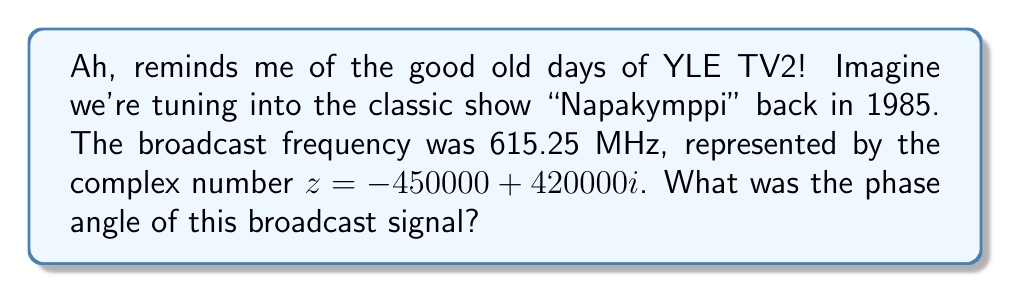Can you answer this question? Let's approach this step-by-step, just like adjusting those old television antennas:

1) The phase angle $\theta$ of a complex number $z = a + bi$ is given by:

   $$\theta = \arctan\left(\frac{b}{a}\right)$$

2) In our case, $a = -450000$ and $b = 420000$

3) Substituting these values:

   $$\theta = \arctan\left(\frac{420000}{-450000}\right)$$

4) Simplify the fraction inside the arctangent:

   $$\theta = \arctan\left(-\frac{14}{15}\right)$$

5) Calculate this value:

   $$\theta \approx -0.7508 \text{ radians}$$

6) However, we need to be careful! When $a$ is negative and $b$ is positive (2nd quadrant), we need to add $\pi$ to our result:

   $$\theta = -0.7508 + \pi \approx 2.3908 \text{ radians}$$

7) Convert to degrees:

   $$\theta \approx 2.3908 \times \frac{180°}{\pi} \approx 137.0°$$
Answer: $137.0°$ 